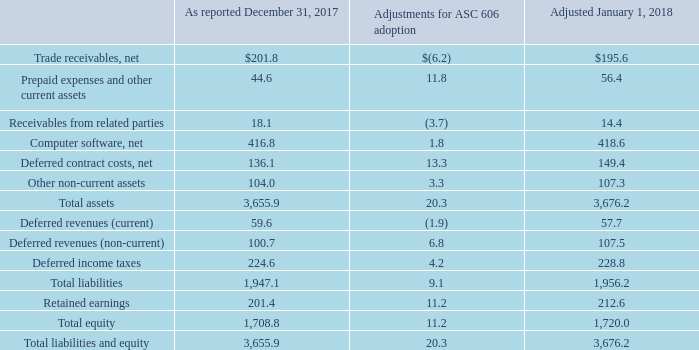Opening Balance Sheet Adjustment on January 1, 2018
As a result of applying the modified retrospective method to adopt ASC 606, the following amounts on our Consolidated Balance Sheet were adjusted as of January 1, 2018 to reflect the cumulative effect adjustment to the opening balance of Retained earnings (in millions):
What were the net trade receivables as reported in 2017?
Answer scale should be: million. 201.8. What were the Receivables from related parties in 2018?
Answer scale should be: million. 14.4. What was the adjustmentments for ASC 606 adoption for net computer software?
Answer scale should be: million. 1.8. What was the difference in amount as reported in 2017 between Total assets and Total liabilities?
Answer scale should be: million. 3,655.9-1,947.1
Answer: 1708.8. What was the difference between current and non-current deferred revenues after adjustment in 2018?
Answer scale should be: million. 100.7-59.6
Answer: 41.1. What was the difference between Total liabilities and equity and Total Equity as reported in 2017?
Answer scale should be: million. 3,655.9-1,708.8
Answer: 1947.1. 